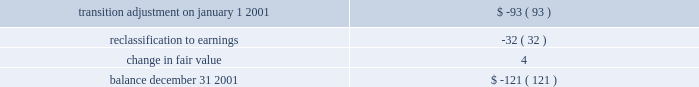Derivative instruments effective january 1 , 2001 , aes adopted sfas no .
133 , 2018 2018accounting for derivative instruments and hedging activities , 2019 2019 which , as amended , establishes accounting and reporting standards for derivative instruments and hedging activities .
The adoption of sfas no .
133 on january 1 , 2001 , resulted in a cumulative reduction to income of less than $ 1 million , net of deferred income tax effects , and a cumulative reduction of accumulated other comprehensive income in stockholders 2019 equity of $ 93 million , net of deferred income tax effects .
For the year ended december 31 , 2001 , the impact of changes in derivative fair value primarily related to derivatives that do not qualify for hedge accounting treatment was a charge of $ 36 million , after income taxes .
This amount includes a charge of $ 6 million , after income taxes , related to the ineffective portion of derivatives qualifying as cash flow and fair value hedges for the year ended december 31 , 2001 .
There was no net effect on results of operations for the year ended december 31 , 2001 , of derivative and non-derivative instruments that have been designated and qualified as hedging net investments in foreign operations .
Approximately $ 35 million of other comprehensive loss related to derivative instruments as of december 31 , 2001 is expected to be recognized as a reduction to earnings over the next twelve months .
A portion of this amount is expected to be offset by the effects of hedge accounting .
The balance in accumulated other comprehensive loss related to derivative transactions will be reclassified into earnings as interest expense is recognized for hedges of interest rate risk , as foreign currency transaction and translation gains and losses are recognized for hedges of foreign currency exposure and as electric and gas sales and purchases are recognized for hedges of forecasted electric and gas transactions .
Amounts recorded in accumulated other comprehensive income , net of tax , during the year-ended december 31 , 2001 , were as follows ( in millions ) : .
Aes utilizes derivative financial instruments to hedge interest rate risk , foreign exchange risk and commodity price risk .
The company utilizes interest rate swap , cap and floor agreements to hedge interest rate risk on floating rate debt .
The majority of aes 2019s interest rate derivatives are designated and qualify as cash flow hedges .
Currency forward and swap agreements are utilized to hedge foreign exchange risk which is a result of aes or one of its subsidiaries entering into monetary obligations in currencies other than its own functional currency .
The majority of aes 2019s foreign currency derivatives are designated and qualify as either fair value hedges or cash flow hedges .
Certain derivative instruments and other non-derivative instruments are designated and qualify as hedges of the foreign currency exposure of a net investment in a foreign operation .
The company utilizes electric and gas derivative instruments , including swaps , options , forwards and futures , to hedge the risk related to electricity and gas sales and purchases .
The majority of aes 2019s electric and gas derivatives are designated and qualify as cash flow hedges .
The maximum length of time over which aes is hedging its exposure to variability in future cash flows for forecasted transactions , excluding forecasted transactions related to the payment of variable interest , is three years .
For the year ended december 31 , 2001 , a charge of $ 4 million , after income taxes , was recorded for two cash flow hedges that were discontinued because it is probable that the hedged forecasted transaction will not occur .
A portion of this charge has been classified as discontinued operations .
For the year ended december 31 , 2001 , no fair value hedges were de-recognized or discontinued. .
For 2001 what was the net change in aoci in millions?\\n? 
Computations: ((93 * const_m1) - -121)
Answer: 28.0. 